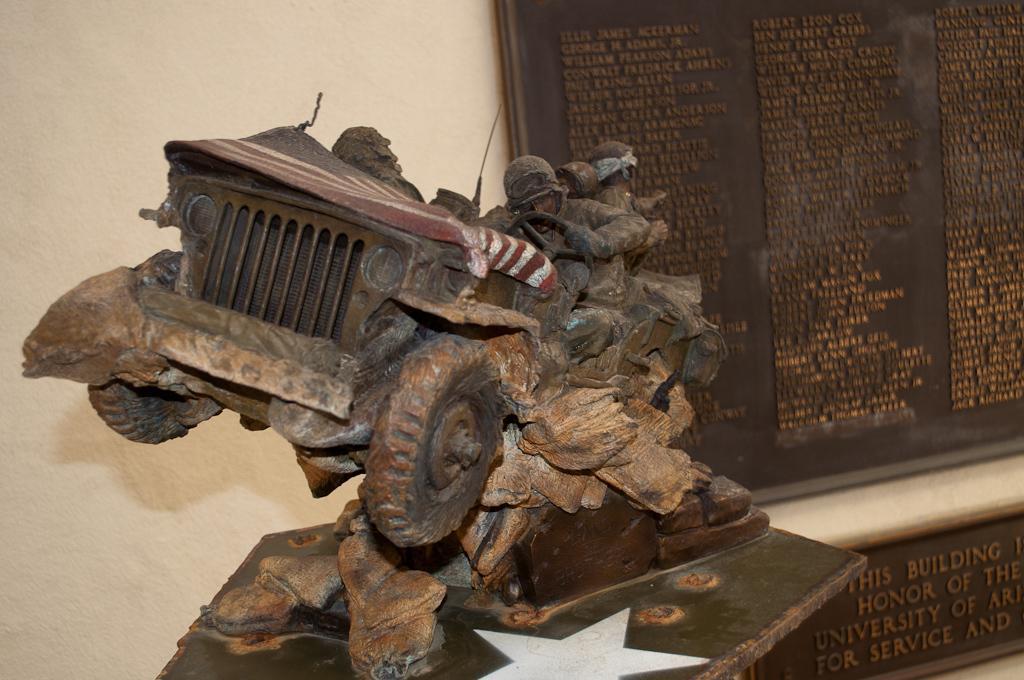Please provide a concise description of this image. In the picture we can see a wooden sculpture of a jeep with some soldiers in it and it is on wooden plank and behind it we can see a wall with a brown color board with many names on it. 